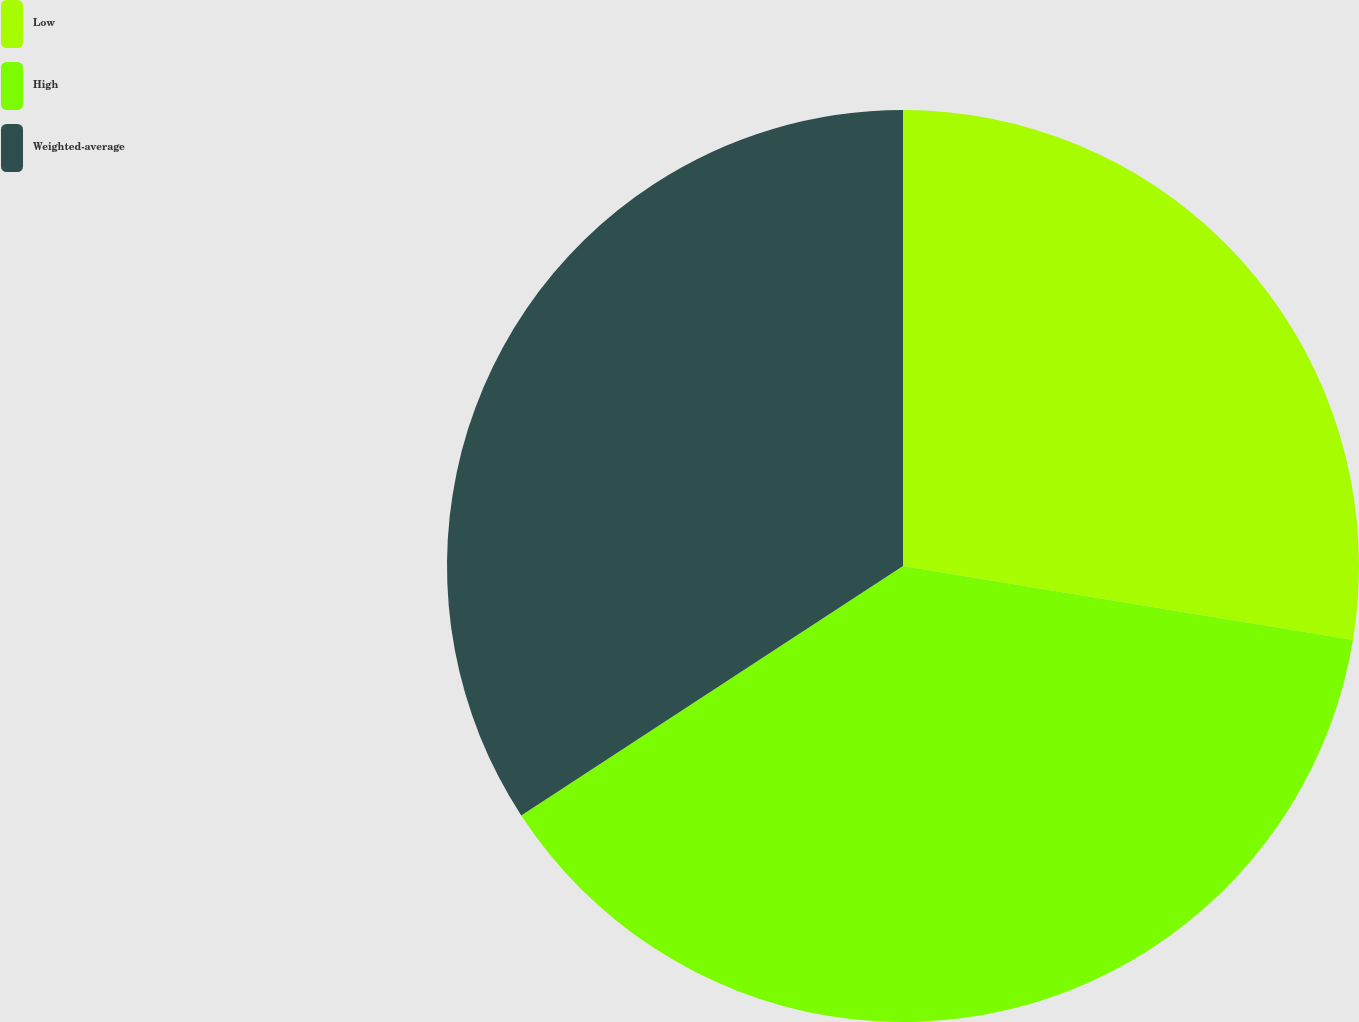Convert chart to OTSL. <chart><loc_0><loc_0><loc_500><loc_500><pie_chart><fcel>Low<fcel>High<fcel>Weighted-average<nl><fcel>27.59%<fcel>38.2%<fcel>34.21%<nl></chart> 